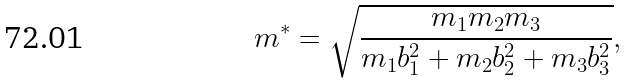Convert formula to latex. <formula><loc_0><loc_0><loc_500><loc_500>m ^ { * } = \sqrt { \frac { m _ { 1 } m _ { 2 } m _ { 3 } } { m _ { 1 } b _ { 1 } ^ { 2 } + m _ { 2 } b _ { 2 } ^ { 2 } + m _ { 3 } b _ { 3 } ^ { 2 } } } ,</formula> 